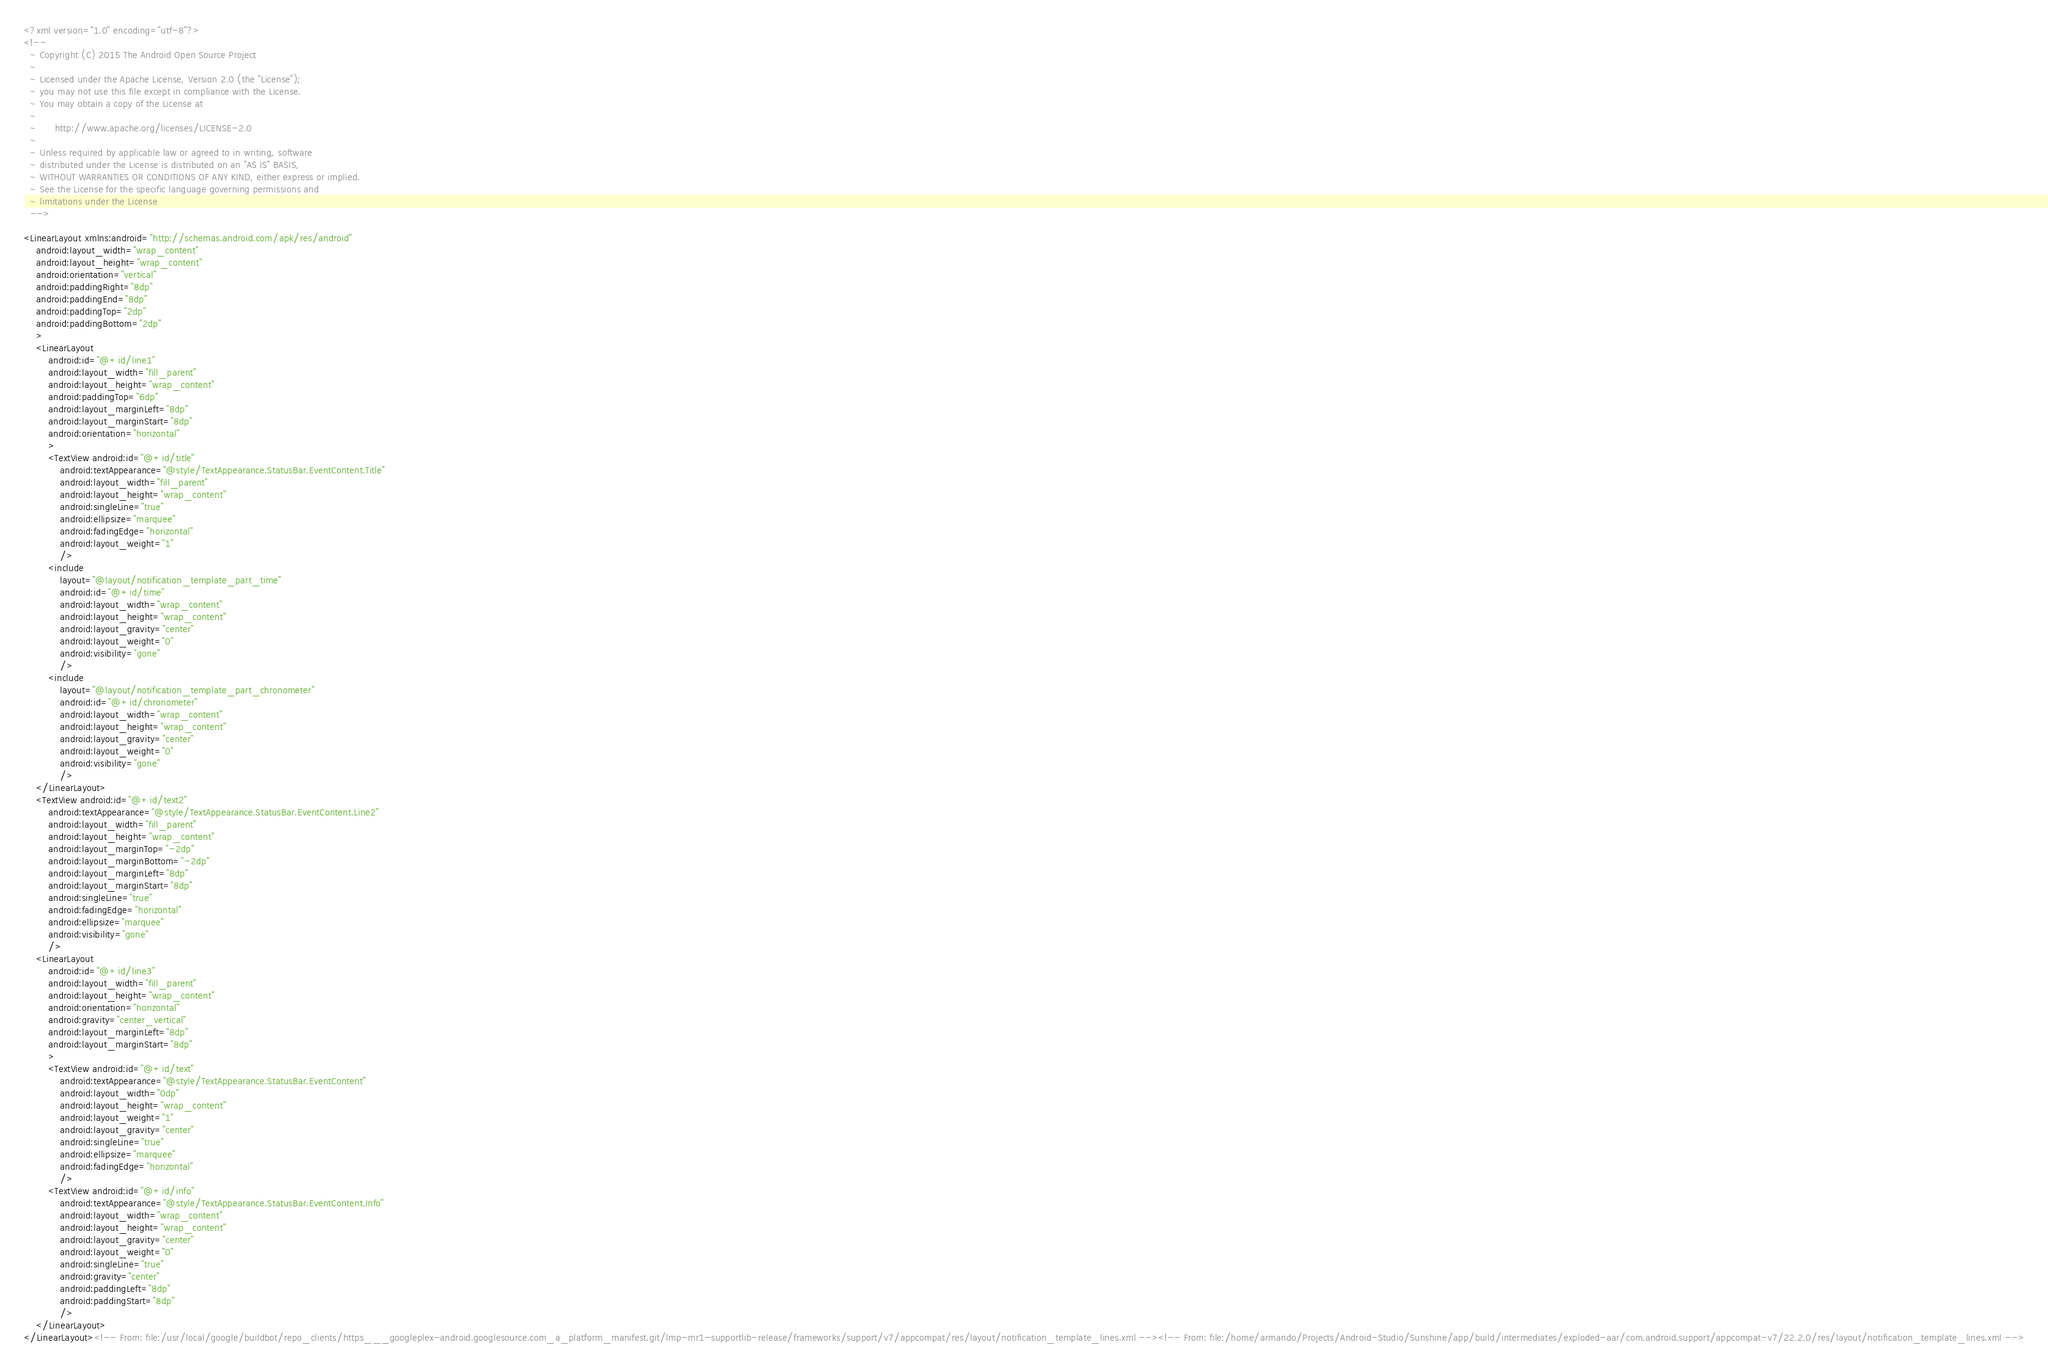<code> <loc_0><loc_0><loc_500><loc_500><_XML_><?xml version="1.0" encoding="utf-8"?>
<!--
  ~ Copyright (C) 2015 The Android Open Source Project
  ~
  ~ Licensed under the Apache License, Version 2.0 (the "License");
  ~ you may not use this file except in compliance with the License.
  ~ You may obtain a copy of the License at
  ~
  ~      http://www.apache.org/licenses/LICENSE-2.0
  ~
  ~ Unless required by applicable law or agreed to in writing, software
  ~ distributed under the License is distributed on an "AS IS" BASIS,
  ~ WITHOUT WARRANTIES OR CONDITIONS OF ANY KIND, either express or implied.
  ~ See the License for the specific language governing permissions and
  ~ limitations under the License
  -->

<LinearLayout xmlns:android="http://schemas.android.com/apk/res/android"
    android:layout_width="wrap_content"
    android:layout_height="wrap_content"
    android:orientation="vertical"
    android:paddingRight="8dp"
    android:paddingEnd="8dp"
    android:paddingTop="2dp"
    android:paddingBottom="2dp"
    >
    <LinearLayout
        android:id="@+id/line1"
        android:layout_width="fill_parent"
        android:layout_height="wrap_content"
        android:paddingTop="6dp"
        android:layout_marginLeft="8dp"
        android:layout_marginStart="8dp"
        android:orientation="horizontal"
        >
        <TextView android:id="@+id/title"
            android:textAppearance="@style/TextAppearance.StatusBar.EventContent.Title"
            android:layout_width="fill_parent"
            android:layout_height="wrap_content"
            android:singleLine="true"
            android:ellipsize="marquee"
            android:fadingEdge="horizontal"
            android:layout_weight="1"
            />
        <include
            layout="@layout/notification_template_part_time"
            android:id="@+id/time"
            android:layout_width="wrap_content"
            android:layout_height="wrap_content"
            android:layout_gravity="center"
            android:layout_weight="0"
            android:visibility="gone"
            />
        <include
            layout="@layout/notification_template_part_chronometer"
            android:id="@+id/chronometer"
            android:layout_width="wrap_content"
            android:layout_height="wrap_content"
            android:layout_gravity="center"
            android:layout_weight="0"
            android:visibility="gone"
            />
    </LinearLayout>
    <TextView android:id="@+id/text2"
        android:textAppearance="@style/TextAppearance.StatusBar.EventContent.Line2"
        android:layout_width="fill_parent"
        android:layout_height="wrap_content"
        android:layout_marginTop="-2dp"
        android:layout_marginBottom="-2dp"
        android:layout_marginLeft="8dp"
        android:layout_marginStart="8dp"
        android:singleLine="true"
        android:fadingEdge="horizontal"
        android:ellipsize="marquee"
        android:visibility="gone"
        />
    <LinearLayout
        android:id="@+id/line3"
        android:layout_width="fill_parent"
        android:layout_height="wrap_content"
        android:orientation="horizontal"
        android:gravity="center_vertical"
        android:layout_marginLeft="8dp"
        android:layout_marginStart="8dp"
        >
        <TextView android:id="@+id/text"
            android:textAppearance="@style/TextAppearance.StatusBar.EventContent"
            android:layout_width="0dp"
            android:layout_height="wrap_content"
            android:layout_weight="1"
            android:layout_gravity="center"
            android:singleLine="true"
            android:ellipsize="marquee"
            android:fadingEdge="horizontal"
            />
        <TextView android:id="@+id/info"
            android:textAppearance="@style/TextAppearance.StatusBar.EventContent.Info"
            android:layout_width="wrap_content"
            android:layout_height="wrap_content"
            android:layout_gravity="center"
            android:layout_weight="0"
            android:singleLine="true"
            android:gravity="center"
            android:paddingLeft="8dp"
            android:paddingStart="8dp"
            />
    </LinearLayout>
</LinearLayout><!-- From: file:/usr/local/google/buildbot/repo_clients/https___googleplex-android.googlesource.com_a_platform_manifest.git/lmp-mr1-supportlib-release/frameworks/support/v7/appcompat/res/layout/notification_template_lines.xml --><!-- From: file:/home/armando/Projects/Android-Studio/Sunshine/app/build/intermediates/exploded-aar/com.android.support/appcompat-v7/22.2.0/res/layout/notification_template_lines.xml --></code> 